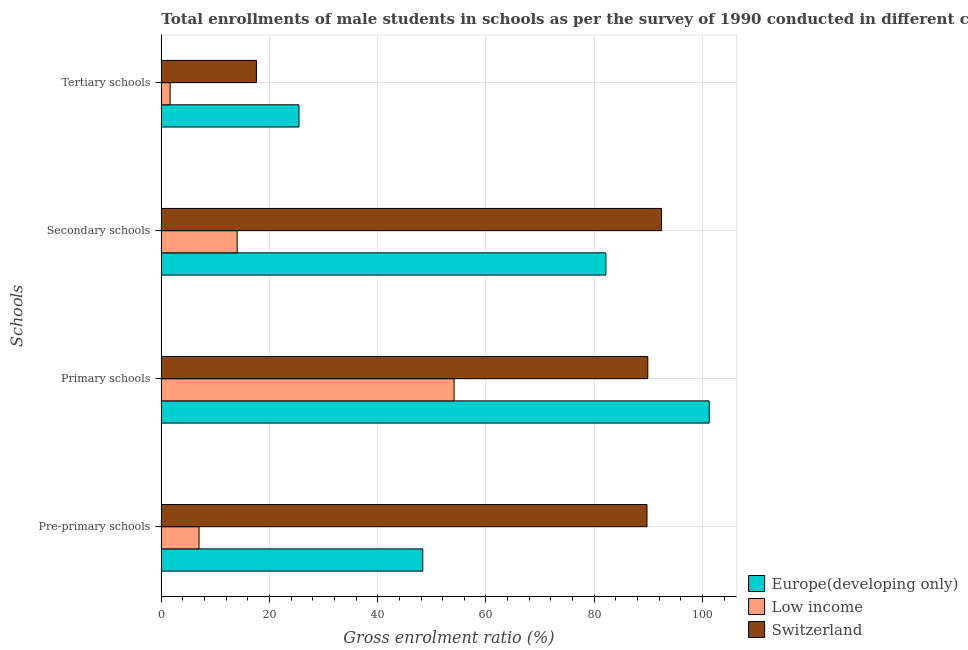Are the number of bars per tick equal to the number of legend labels?
Ensure brevity in your answer.  Yes. What is the label of the 4th group of bars from the top?
Your answer should be compact. Pre-primary schools. What is the gross enrolment ratio(male) in pre-primary schools in Switzerland?
Ensure brevity in your answer.  89.76. Across all countries, what is the maximum gross enrolment ratio(male) in primary schools?
Your answer should be very brief. 101.26. Across all countries, what is the minimum gross enrolment ratio(male) in tertiary schools?
Provide a succinct answer. 1.62. In which country was the gross enrolment ratio(male) in pre-primary schools maximum?
Your answer should be very brief. Switzerland. In which country was the gross enrolment ratio(male) in primary schools minimum?
Offer a terse response. Low income. What is the total gross enrolment ratio(male) in pre-primary schools in the graph?
Provide a short and direct response. 145.05. What is the difference between the gross enrolment ratio(male) in primary schools in Switzerland and that in Low income?
Provide a short and direct response. 35.8. What is the difference between the gross enrolment ratio(male) in primary schools in Switzerland and the gross enrolment ratio(male) in tertiary schools in Europe(developing only)?
Your answer should be very brief. 64.46. What is the average gross enrolment ratio(male) in primary schools per country?
Make the answer very short. 81.76. What is the difference between the gross enrolment ratio(male) in secondary schools and gross enrolment ratio(male) in tertiary schools in Switzerland?
Ensure brevity in your answer.  74.86. In how many countries, is the gross enrolment ratio(male) in pre-primary schools greater than 24 %?
Ensure brevity in your answer.  2. What is the ratio of the gross enrolment ratio(male) in tertiary schools in Switzerland to that in Europe(developing only)?
Offer a very short reply. 0.69. Is the difference between the gross enrolment ratio(male) in secondary schools in Low income and Europe(developing only) greater than the difference between the gross enrolment ratio(male) in primary schools in Low income and Europe(developing only)?
Provide a succinct answer. No. What is the difference between the highest and the second highest gross enrolment ratio(male) in pre-primary schools?
Give a very brief answer. 41.44. What is the difference between the highest and the lowest gross enrolment ratio(male) in secondary schools?
Offer a very short reply. 78.42. Is it the case that in every country, the sum of the gross enrolment ratio(male) in primary schools and gross enrolment ratio(male) in tertiary schools is greater than the sum of gross enrolment ratio(male) in secondary schools and gross enrolment ratio(male) in pre-primary schools?
Provide a short and direct response. No. What does the 1st bar from the top in Tertiary schools represents?
Provide a succinct answer. Switzerland. What does the 1st bar from the bottom in Primary schools represents?
Provide a succinct answer. Europe(developing only). Are all the bars in the graph horizontal?
Your response must be concise. Yes. How many countries are there in the graph?
Keep it short and to the point. 3. What is the difference between two consecutive major ticks on the X-axis?
Offer a very short reply. 20. Are the values on the major ticks of X-axis written in scientific E-notation?
Your answer should be compact. No. Does the graph contain grids?
Offer a terse response. Yes. How many legend labels are there?
Give a very brief answer. 3. How are the legend labels stacked?
Ensure brevity in your answer.  Vertical. What is the title of the graph?
Your answer should be compact. Total enrollments of male students in schools as per the survey of 1990 conducted in different countries. Does "Mozambique" appear as one of the legend labels in the graph?
Provide a succinct answer. No. What is the label or title of the Y-axis?
Make the answer very short. Schools. What is the Gross enrolment ratio (%) in Europe(developing only) in Pre-primary schools?
Keep it short and to the point. 48.32. What is the Gross enrolment ratio (%) in Low income in Pre-primary schools?
Make the answer very short. 6.97. What is the Gross enrolment ratio (%) of Switzerland in Pre-primary schools?
Make the answer very short. 89.76. What is the Gross enrolment ratio (%) of Europe(developing only) in Primary schools?
Your response must be concise. 101.26. What is the Gross enrolment ratio (%) of Low income in Primary schools?
Your answer should be very brief. 54.11. What is the Gross enrolment ratio (%) of Switzerland in Primary schools?
Your answer should be compact. 89.91. What is the Gross enrolment ratio (%) of Europe(developing only) in Secondary schools?
Your answer should be very brief. 82.17. What is the Gross enrolment ratio (%) in Low income in Secondary schools?
Offer a very short reply. 14.01. What is the Gross enrolment ratio (%) of Switzerland in Secondary schools?
Keep it short and to the point. 92.44. What is the Gross enrolment ratio (%) in Europe(developing only) in Tertiary schools?
Your answer should be very brief. 25.45. What is the Gross enrolment ratio (%) of Low income in Tertiary schools?
Offer a terse response. 1.62. What is the Gross enrolment ratio (%) in Switzerland in Tertiary schools?
Your answer should be very brief. 17.57. Across all Schools, what is the maximum Gross enrolment ratio (%) in Europe(developing only)?
Offer a terse response. 101.26. Across all Schools, what is the maximum Gross enrolment ratio (%) in Low income?
Ensure brevity in your answer.  54.11. Across all Schools, what is the maximum Gross enrolment ratio (%) in Switzerland?
Ensure brevity in your answer.  92.44. Across all Schools, what is the minimum Gross enrolment ratio (%) of Europe(developing only)?
Your answer should be compact. 25.45. Across all Schools, what is the minimum Gross enrolment ratio (%) of Low income?
Ensure brevity in your answer.  1.62. Across all Schools, what is the minimum Gross enrolment ratio (%) of Switzerland?
Offer a terse response. 17.57. What is the total Gross enrolment ratio (%) in Europe(developing only) in the graph?
Your answer should be very brief. 257.18. What is the total Gross enrolment ratio (%) of Low income in the graph?
Ensure brevity in your answer.  76.71. What is the total Gross enrolment ratio (%) in Switzerland in the graph?
Provide a succinct answer. 289.67. What is the difference between the Gross enrolment ratio (%) in Europe(developing only) in Pre-primary schools and that in Primary schools?
Ensure brevity in your answer.  -52.94. What is the difference between the Gross enrolment ratio (%) of Low income in Pre-primary schools and that in Primary schools?
Make the answer very short. -47.13. What is the difference between the Gross enrolment ratio (%) in Switzerland in Pre-primary schools and that in Primary schools?
Provide a succinct answer. -0.15. What is the difference between the Gross enrolment ratio (%) of Europe(developing only) in Pre-primary schools and that in Secondary schools?
Ensure brevity in your answer.  -33.85. What is the difference between the Gross enrolment ratio (%) in Low income in Pre-primary schools and that in Secondary schools?
Your answer should be very brief. -7.04. What is the difference between the Gross enrolment ratio (%) of Switzerland in Pre-primary schools and that in Secondary schools?
Your answer should be compact. -2.68. What is the difference between the Gross enrolment ratio (%) of Europe(developing only) in Pre-primary schools and that in Tertiary schools?
Offer a terse response. 22.87. What is the difference between the Gross enrolment ratio (%) in Low income in Pre-primary schools and that in Tertiary schools?
Make the answer very short. 5.35. What is the difference between the Gross enrolment ratio (%) of Switzerland in Pre-primary schools and that in Tertiary schools?
Your answer should be compact. 72.18. What is the difference between the Gross enrolment ratio (%) of Europe(developing only) in Primary schools and that in Secondary schools?
Provide a short and direct response. 19.09. What is the difference between the Gross enrolment ratio (%) of Low income in Primary schools and that in Secondary schools?
Your answer should be compact. 40.09. What is the difference between the Gross enrolment ratio (%) of Switzerland in Primary schools and that in Secondary schools?
Your response must be concise. -2.53. What is the difference between the Gross enrolment ratio (%) of Europe(developing only) in Primary schools and that in Tertiary schools?
Your answer should be compact. 75.81. What is the difference between the Gross enrolment ratio (%) in Low income in Primary schools and that in Tertiary schools?
Your response must be concise. 52.48. What is the difference between the Gross enrolment ratio (%) in Switzerland in Primary schools and that in Tertiary schools?
Give a very brief answer. 72.33. What is the difference between the Gross enrolment ratio (%) of Europe(developing only) in Secondary schools and that in Tertiary schools?
Ensure brevity in your answer.  56.72. What is the difference between the Gross enrolment ratio (%) of Low income in Secondary schools and that in Tertiary schools?
Ensure brevity in your answer.  12.39. What is the difference between the Gross enrolment ratio (%) in Switzerland in Secondary schools and that in Tertiary schools?
Offer a very short reply. 74.86. What is the difference between the Gross enrolment ratio (%) in Europe(developing only) in Pre-primary schools and the Gross enrolment ratio (%) in Low income in Primary schools?
Make the answer very short. -5.79. What is the difference between the Gross enrolment ratio (%) in Europe(developing only) in Pre-primary schools and the Gross enrolment ratio (%) in Switzerland in Primary schools?
Offer a very short reply. -41.59. What is the difference between the Gross enrolment ratio (%) in Low income in Pre-primary schools and the Gross enrolment ratio (%) in Switzerland in Primary schools?
Provide a short and direct response. -82.94. What is the difference between the Gross enrolment ratio (%) of Europe(developing only) in Pre-primary schools and the Gross enrolment ratio (%) of Low income in Secondary schools?
Keep it short and to the point. 34.31. What is the difference between the Gross enrolment ratio (%) of Europe(developing only) in Pre-primary schools and the Gross enrolment ratio (%) of Switzerland in Secondary schools?
Your answer should be compact. -44.12. What is the difference between the Gross enrolment ratio (%) in Low income in Pre-primary schools and the Gross enrolment ratio (%) in Switzerland in Secondary schools?
Make the answer very short. -85.47. What is the difference between the Gross enrolment ratio (%) of Europe(developing only) in Pre-primary schools and the Gross enrolment ratio (%) of Low income in Tertiary schools?
Your answer should be very brief. 46.69. What is the difference between the Gross enrolment ratio (%) in Europe(developing only) in Pre-primary schools and the Gross enrolment ratio (%) in Switzerland in Tertiary schools?
Keep it short and to the point. 30.74. What is the difference between the Gross enrolment ratio (%) of Low income in Pre-primary schools and the Gross enrolment ratio (%) of Switzerland in Tertiary schools?
Offer a terse response. -10.6. What is the difference between the Gross enrolment ratio (%) in Europe(developing only) in Primary schools and the Gross enrolment ratio (%) in Low income in Secondary schools?
Make the answer very short. 87.24. What is the difference between the Gross enrolment ratio (%) of Europe(developing only) in Primary schools and the Gross enrolment ratio (%) of Switzerland in Secondary schools?
Ensure brevity in your answer.  8.82. What is the difference between the Gross enrolment ratio (%) in Low income in Primary schools and the Gross enrolment ratio (%) in Switzerland in Secondary schools?
Offer a very short reply. -38.33. What is the difference between the Gross enrolment ratio (%) of Europe(developing only) in Primary schools and the Gross enrolment ratio (%) of Low income in Tertiary schools?
Give a very brief answer. 99.63. What is the difference between the Gross enrolment ratio (%) of Europe(developing only) in Primary schools and the Gross enrolment ratio (%) of Switzerland in Tertiary schools?
Give a very brief answer. 83.68. What is the difference between the Gross enrolment ratio (%) in Low income in Primary schools and the Gross enrolment ratio (%) in Switzerland in Tertiary schools?
Offer a terse response. 36.53. What is the difference between the Gross enrolment ratio (%) of Europe(developing only) in Secondary schools and the Gross enrolment ratio (%) of Low income in Tertiary schools?
Keep it short and to the point. 80.54. What is the difference between the Gross enrolment ratio (%) of Europe(developing only) in Secondary schools and the Gross enrolment ratio (%) of Switzerland in Tertiary schools?
Give a very brief answer. 64.59. What is the difference between the Gross enrolment ratio (%) in Low income in Secondary schools and the Gross enrolment ratio (%) in Switzerland in Tertiary schools?
Keep it short and to the point. -3.56. What is the average Gross enrolment ratio (%) of Europe(developing only) per Schools?
Your response must be concise. 64.3. What is the average Gross enrolment ratio (%) of Low income per Schools?
Provide a succinct answer. 19.18. What is the average Gross enrolment ratio (%) of Switzerland per Schools?
Your response must be concise. 72.42. What is the difference between the Gross enrolment ratio (%) of Europe(developing only) and Gross enrolment ratio (%) of Low income in Pre-primary schools?
Make the answer very short. 41.35. What is the difference between the Gross enrolment ratio (%) in Europe(developing only) and Gross enrolment ratio (%) in Switzerland in Pre-primary schools?
Your answer should be compact. -41.44. What is the difference between the Gross enrolment ratio (%) of Low income and Gross enrolment ratio (%) of Switzerland in Pre-primary schools?
Your response must be concise. -82.79. What is the difference between the Gross enrolment ratio (%) of Europe(developing only) and Gross enrolment ratio (%) of Low income in Primary schools?
Make the answer very short. 47.15. What is the difference between the Gross enrolment ratio (%) of Europe(developing only) and Gross enrolment ratio (%) of Switzerland in Primary schools?
Keep it short and to the point. 11.35. What is the difference between the Gross enrolment ratio (%) of Low income and Gross enrolment ratio (%) of Switzerland in Primary schools?
Your response must be concise. -35.8. What is the difference between the Gross enrolment ratio (%) in Europe(developing only) and Gross enrolment ratio (%) in Low income in Secondary schools?
Offer a very short reply. 68.15. What is the difference between the Gross enrolment ratio (%) in Europe(developing only) and Gross enrolment ratio (%) in Switzerland in Secondary schools?
Offer a terse response. -10.27. What is the difference between the Gross enrolment ratio (%) in Low income and Gross enrolment ratio (%) in Switzerland in Secondary schools?
Offer a terse response. -78.42. What is the difference between the Gross enrolment ratio (%) in Europe(developing only) and Gross enrolment ratio (%) in Low income in Tertiary schools?
Provide a succinct answer. 23.82. What is the difference between the Gross enrolment ratio (%) of Europe(developing only) and Gross enrolment ratio (%) of Switzerland in Tertiary schools?
Ensure brevity in your answer.  7.87. What is the difference between the Gross enrolment ratio (%) in Low income and Gross enrolment ratio (%) in Switzerland in Tertiary schools?
Provide a succinct answer. -15.95. What is the ratio of the Gross enrolment ratio (%) in Europe(developing only) in Pre-primary schools to that in Primary schools?
Make the answer very short. 0.48. What is the ratio of the Gross enrolment ratio (%) in Low income in Pre-primary schools to that in Primary schools?
Offer a terse response. 0.13. What is the ratio of the Gross enrolment ratio (%) in Switzerland in Pre-primary schools to that in Primary schools?
Ensure brevity in your answer.  1. What is the ratio of the Gross enrolment ratio (%) in Europe(developing only) in Pre-primary schools to that in Secondary schools?
Your answer should be compact. 0.59. What is the ratio of the Gross enrolment ratio (%) of Low income in Pre-primary schools to that in Secondary schools?
Keep it short and to the point. 0.5. What is the ratio of the Gross enrolment ratio (%) in Europe(developing only) in Pre-primary schools to that in Tertiary schools?
Make the answer very short. 1.9. What is the ratio of the Gross enrolment ratio (%) of Low income in Pre-primary schools to that in Tertiary schools?
Keep it short and to the point. 4.29. What is the ratio of the Gross enrolment ratio (%) of Switzerland in Pre-primary schools to that in Tertiary schools?
Offer a terse response. 5.11. What is the ratio of the Gross enrolment ratio (%) of Europe(developing only) in Primary schools to that in Secondary schools?
Make the answer very short. 1.23. What is the ratio of the Gross enrolment ratio (%) of Low income in Primary schools to that in Secondary schools?
Offer a terse response. 3.86. What is the ratio of the Gross enrolment ratio (%) of Switzerland in Primary schools to that in Secondary schools?
Your answer should be very brief. 0.97. What is the ratio of the Gross enrolment ratio (%) of Europe(developing only) in Primary schools to that in Tertiary schools?
Give a very brief answer. 3.98. What is the ratio of the Gross enrolment ratio (%) of Low income in Primary schools to that in Tertiary schools?
Offer a terse response. 33.31. What is the ratio of the Gross enrolment ratio (%) in Switzerland in Primary schools to that in Tertiary schools?
Provide a succinct answer. 5.12. What is the ratio of the Gross enrolment ratio (%) in Europe(developing only) in Secondary schools to that in Tertiary schools?
Offer a terse response. 3.23. What is the ratio of the Gross enrolment ratio (%) of Low income in Secondary schools to that in Tertiary schools?
Keep it short and to the point. 8.63. What is the ratio of the Gross enrolment ratio (%) of Switzerland in Secondary schools to that in Tertiary schools?
Offer a terse response. 5.26. What is the difference between the highest and the second highest Gross enrolment ratio (%) of Europe(developing only)?
Make the answer very short. 19.09. What is the difference between the highest and the second highest Gross enrolment ratio (%) in Low income?
Your answer should be very brief. 40.09. What is the difference between the highest and the second highest Gross enrolment ratio (%) of Switzerland?
Your answer should be very brief. 2.53. What is the difference between the highest and the lowest Gross enrolment ratio (%) in Europe(developing only)?
Make the answer very short. 75.81. What is the difference between the highest and the lowest Gross enrolment ratio (%) in Low income?
Offer a terse response. 52.48. What is the difference between the highest and the lowest Gross enrolment ratio (%) of Switzerland?
Your answer should be very brief. 74.86. 